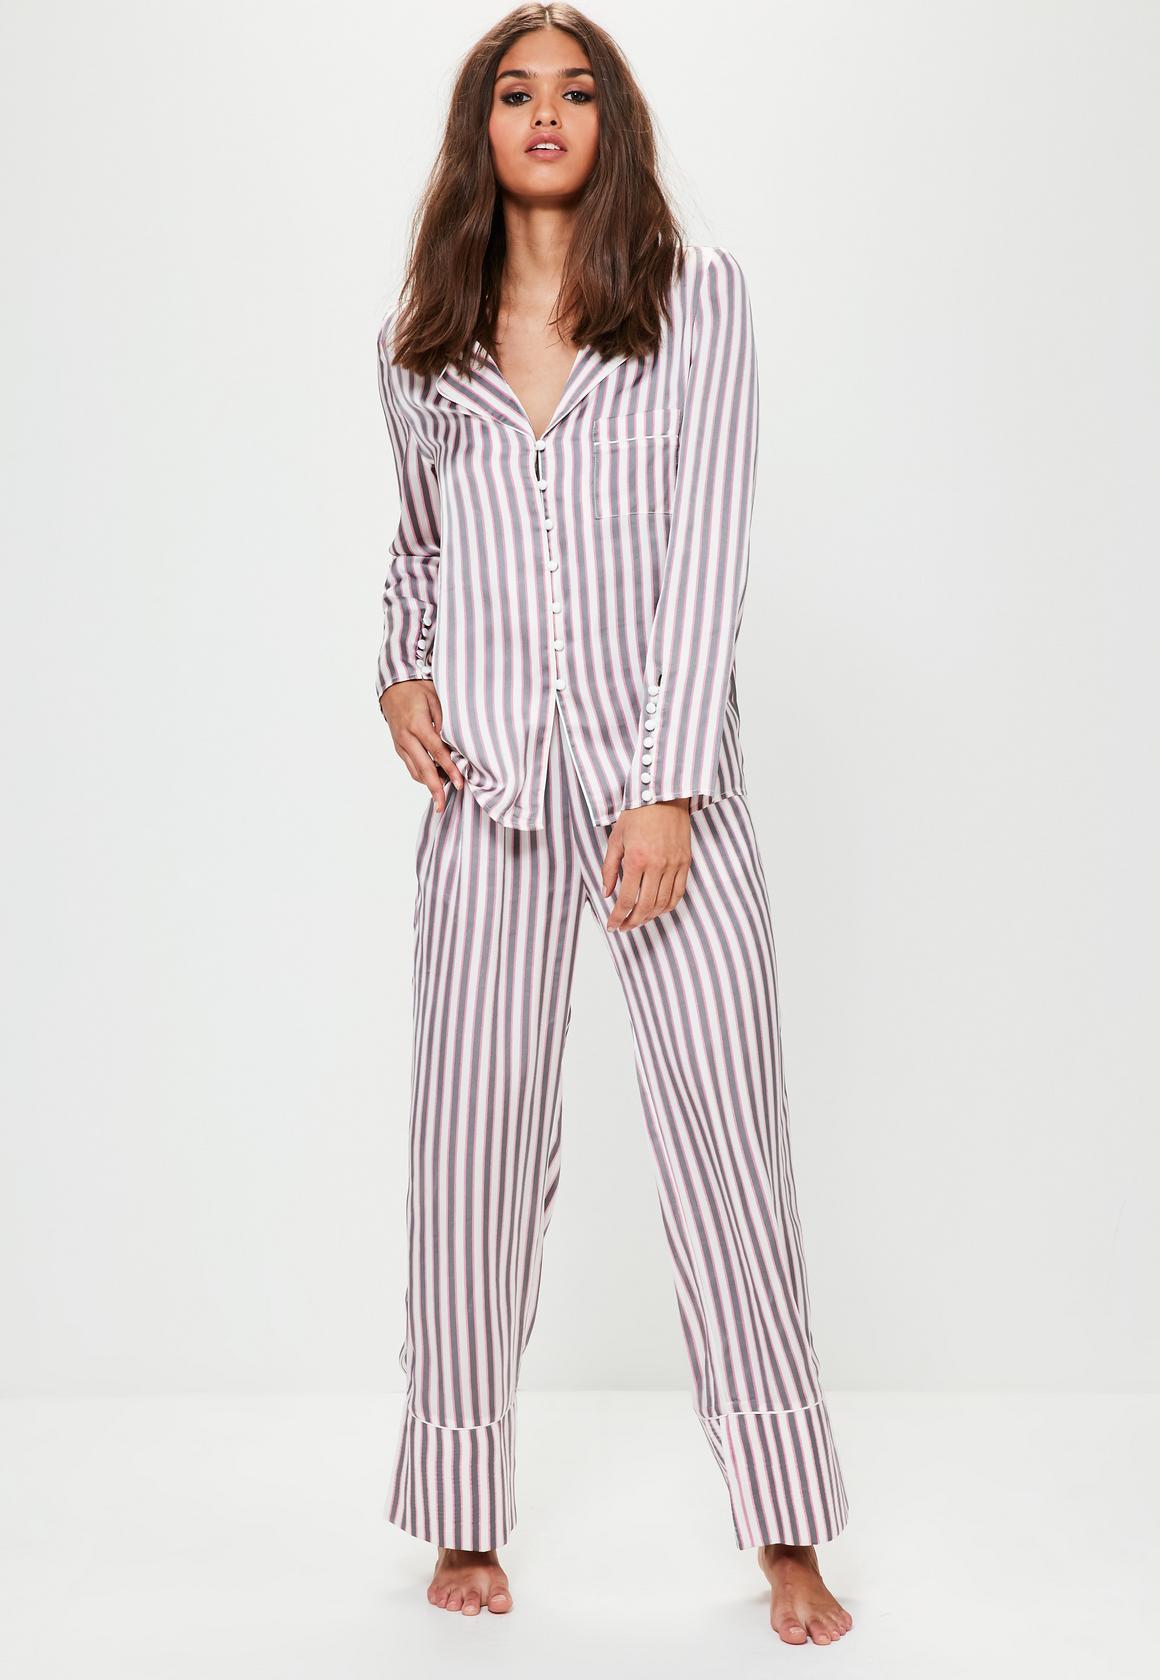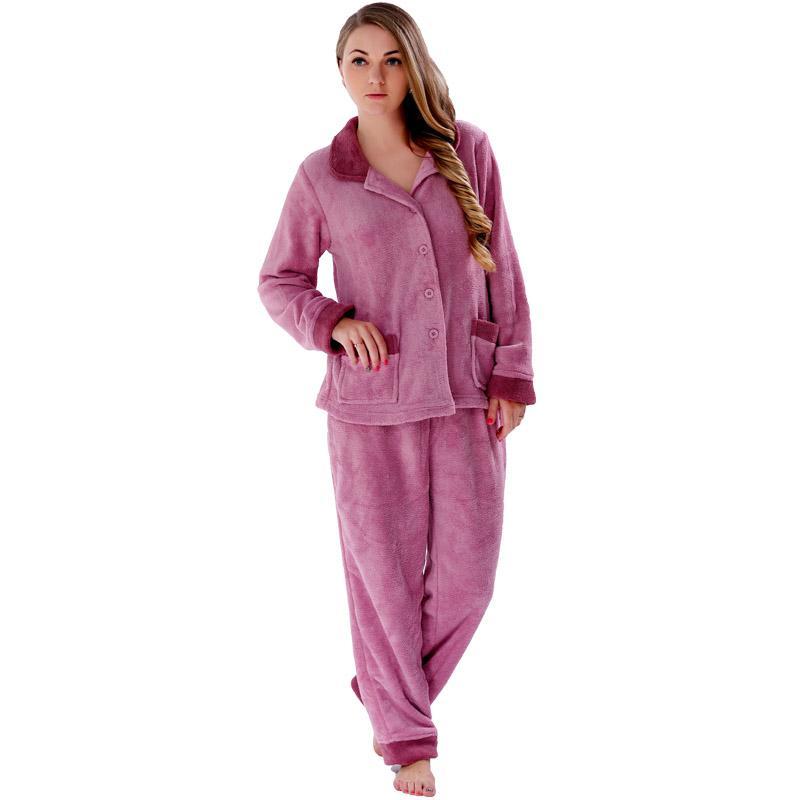The first image is the image on the left, the second image is the image on the right. Given the left and right images, does the statement "Each model wears printed pajamas, and each pajama outfit includes a button-up top with a shirt collar." hold true? Answer yes or no. No. The first image is the image on the left, the second image is the image on the right. Considering the images on both sides, is "Both models are wearing the same design of pajamas." valid? Answer yes or no. No. 